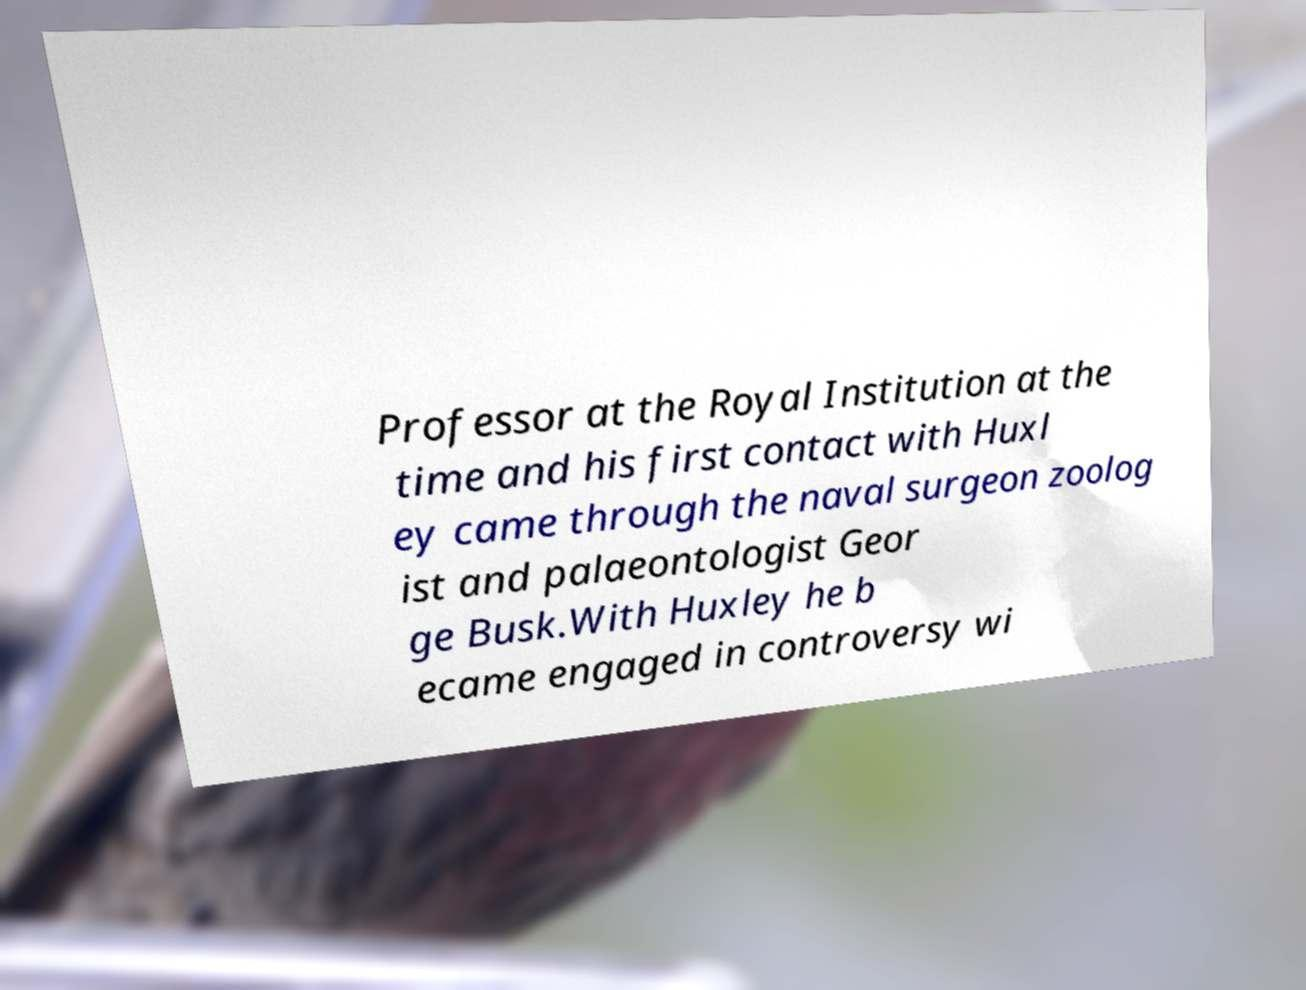Please identify and transcribe the text found in this image. Professor at the Royal Institution at the time and his first contact with Huxl ey came through the naval surgeon zoolog ist and palaeontologist Geor ge Busk.With Huxley he b ecame engaged in controversy wi 